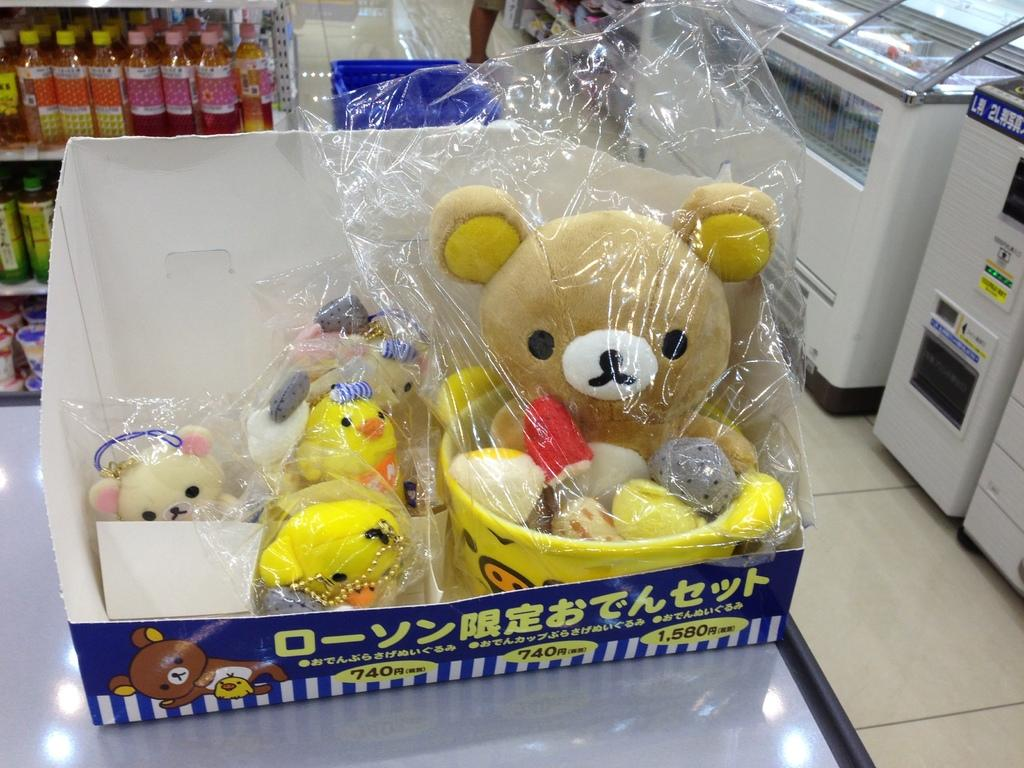What objects are inside the box in the image? There are toys in a box in the image. Where is the box located? The box is on a table in the image. What can be seen in the rack in the image? There are bottles in a rack in the image. What can be found in the top right corner of the image? There are counters in the top right of the image. What type of spark can be seen coming from the toys in the image? There is no spark present in the image; it features toys in a box on a table. How many times do the bottles smash against the counters in the image? There are no bottles smashing against the counters in the image; it shows bottles in a rack and counters in the top right corner. 